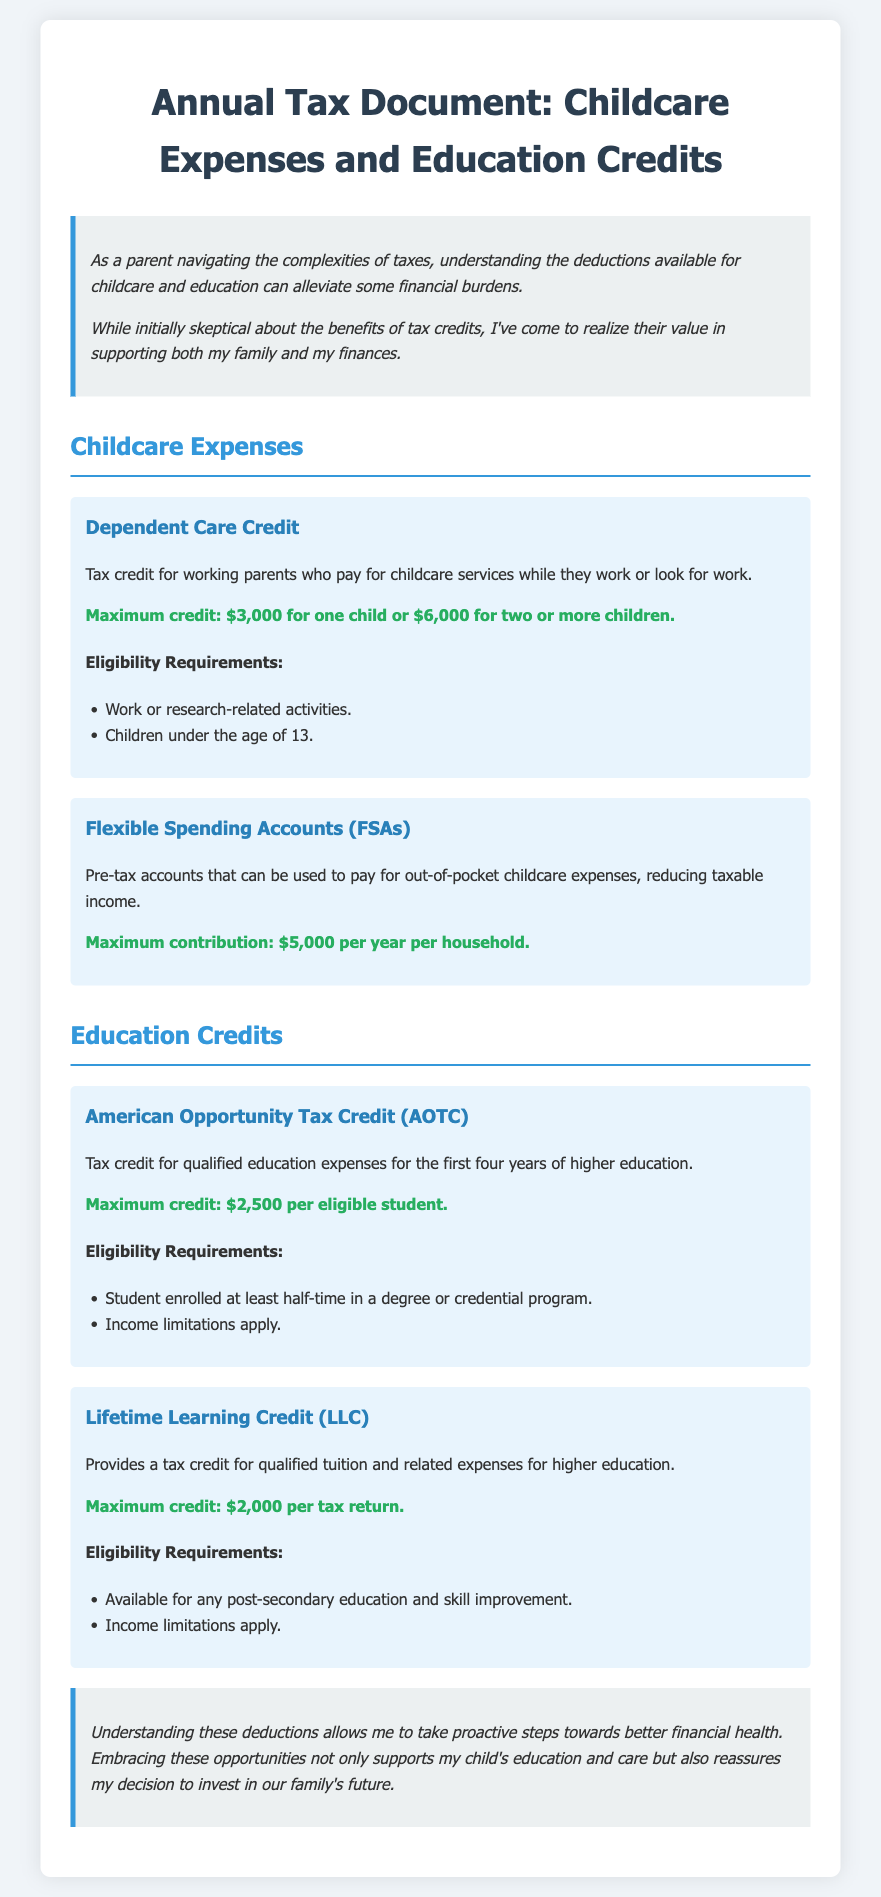What is the maximum credit for the Dependent Care Credit? The maximum credit for the Dependent Care Credit is outlined in the document, which states it as $3,000 for one child or $6,000 for two or more children.
Answer: $6,000 What is the maximum contribution for Flexible Spending Accounts? The document specifies that the maximum contribution for FSAs is $5,000 per year per household.
Answer: $5,000 What is the maximum credit for the American Opportunity Tax Credit? The document provides the specific maximum credit available, which is $2,500 per eligible student.
Answer: $2,500 What is one eligibility requirement for the Lifetime Learning Credit? The document lists eligibility requirements, including that it's available for any post-secondary education and skill improvement.
Answer: Post-secondary education How many years of higher education does the American Opportunity Tax Credit cover? The document states that the AOTC applies to the first four years of higher education.
Answer: Four years What must students be enrolled in to qualify for the American Opportunity Tax Credit? The document specifies that students must be enrolled at least half-time in a degree or credential program.
Answer: Half-time What do flexible spending accounts help to reduce? The document explains that FSAs reduce taxable income by being used for pre-tax payments of out-of-pocket childcare expenses.
Answer: Taxable income What type of expenses does the Lifetime Learning Credit cover? The document defines that the LLC is for qualified tuition and related expenses for higher education.
Answer: Tuition and related expenses 